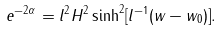Convert formula to latex. <formula><loc_0><loc_0><loc_500><loc_500>e ^ { - 2 \alpha } = l ^ { 2 } H ^ { 2 } \sinh ^ { 2 } [ l ^ { - 1 } ( w - w _ { 0 } ) ] .</formula> 